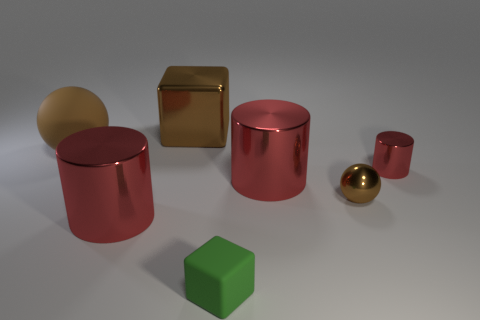Subtract all red cylinders. How many were subtracted if there are1red cylinders left? 2 Subtract all tiny cylinders. How many cylinders are left? 2 Add 1 blocks. How many objects exist? 8 Subtract 1 spheres. How many spheres are left? 1 Subtract all tiny red blocks. Subtract all shiny spheres. How many objects are left? 6 Add 7 tiny red things. How many tiny red things are left? 8 Add 6 tiny green matte things. How many tiny green matte things exist? 7 Subtract 0 cyan cylinders. How many objects are left? 7 Subtract all spheres. How many objects are left? 5 Subtract all brown cylinders. Subtract all green cubes. How many cylinders are left? 3 